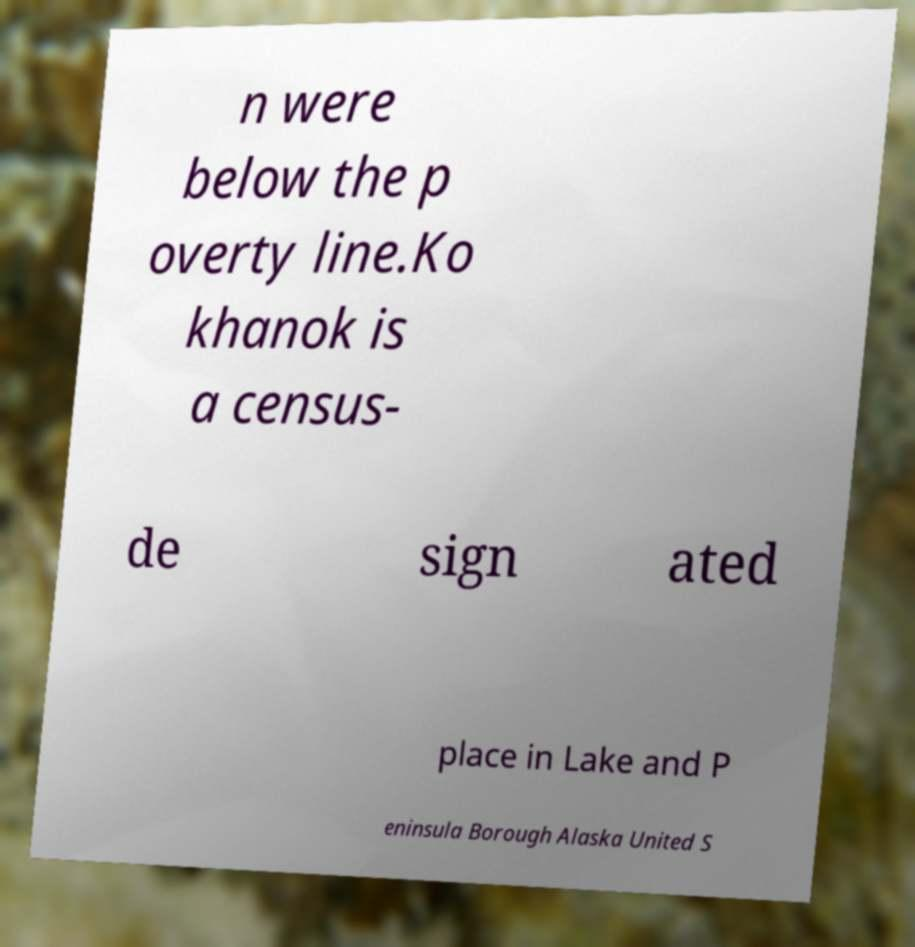Please read and relay the text visible in this image. What does it say? n were below the p overty line.Ko khanok is a census- de sign ated place in Lake and P eninsula Borough Alaska United S 